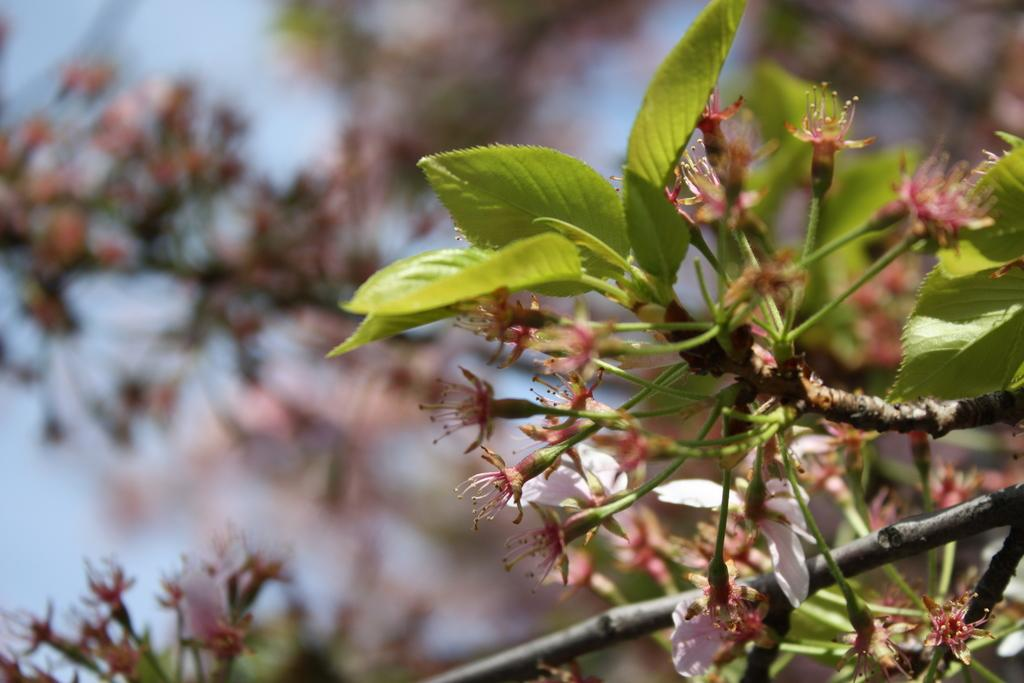What type of living organisms are present in the image? There are plants in the image. What specific features can be observed on the plants? The plants have flowers and leaves. What can be seen in the background of the image? The sky is visible in the background of the image. What type of pencil can be seen in the image? There is no pencil present in the image. How many apples are visible in the image? There are no apples present in the image. 